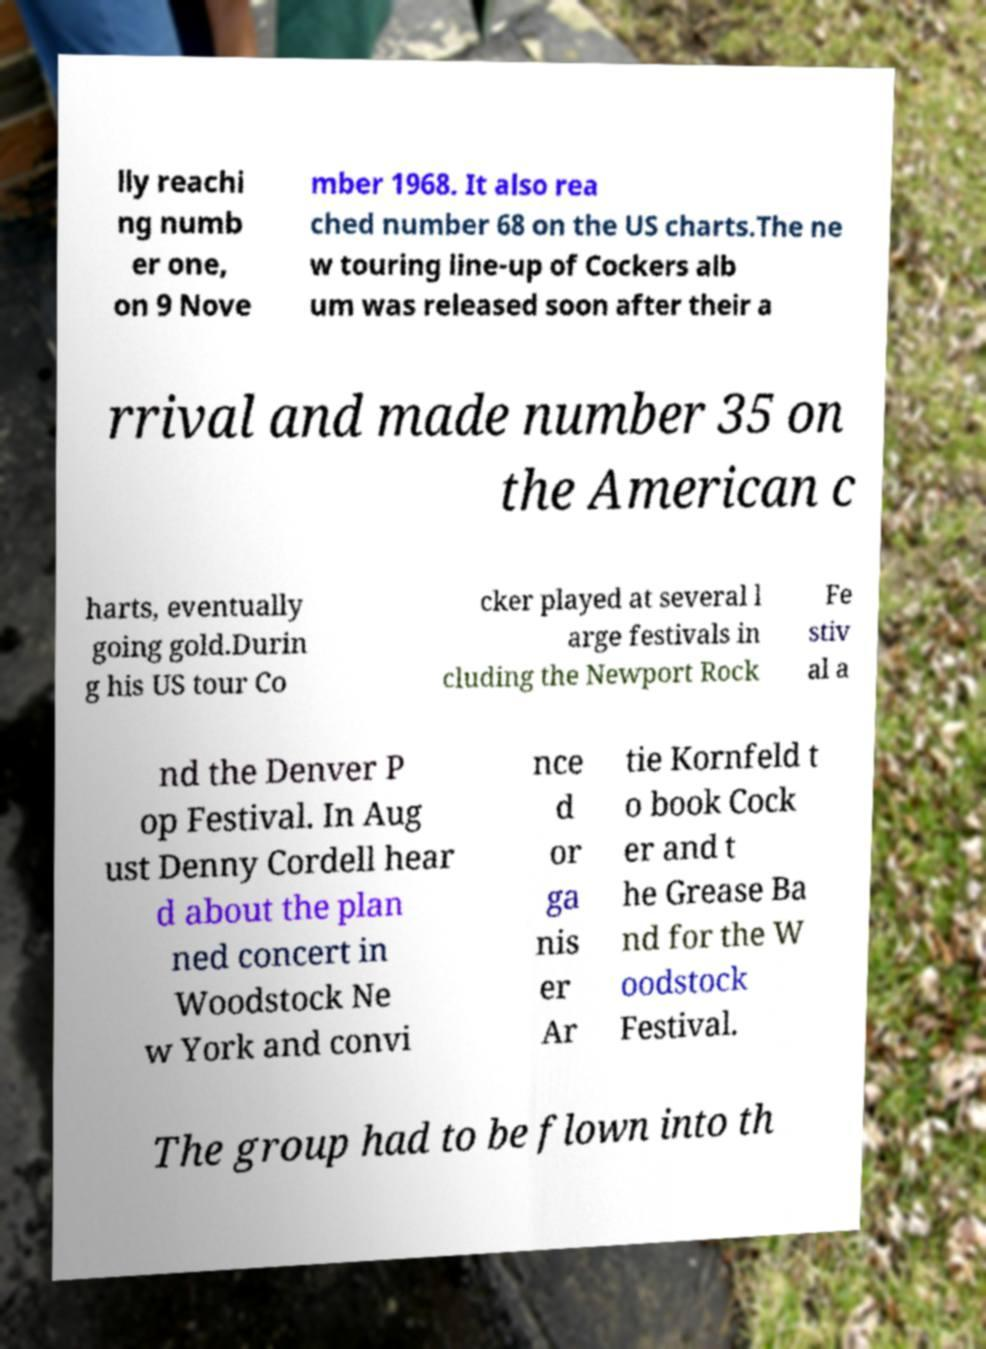I need the written content from this picture converted into text. Can you do that? lly reachi ng numb er one, on 9 Nove mber 1968. It also rea ched number 68 on the US charts.The ne w touring line-up of Cockers alb um was released soon after their a rrival and made number 35 on the American c harts, eventually going gold.Durin g his US tour Co cker played at several l arge festivals in cluding the Newport Rock Fe stiv al a nd the Denver P op Festival. In Aug ust Denny Cordell hear d about the plan ned concert in Woodstock Ne w York and convi nce d or ga nis er Ar tie Kornfeld t o book Cock er and t he Grease Ba nd for the W oodstock Festival. The group had to be flown into th 